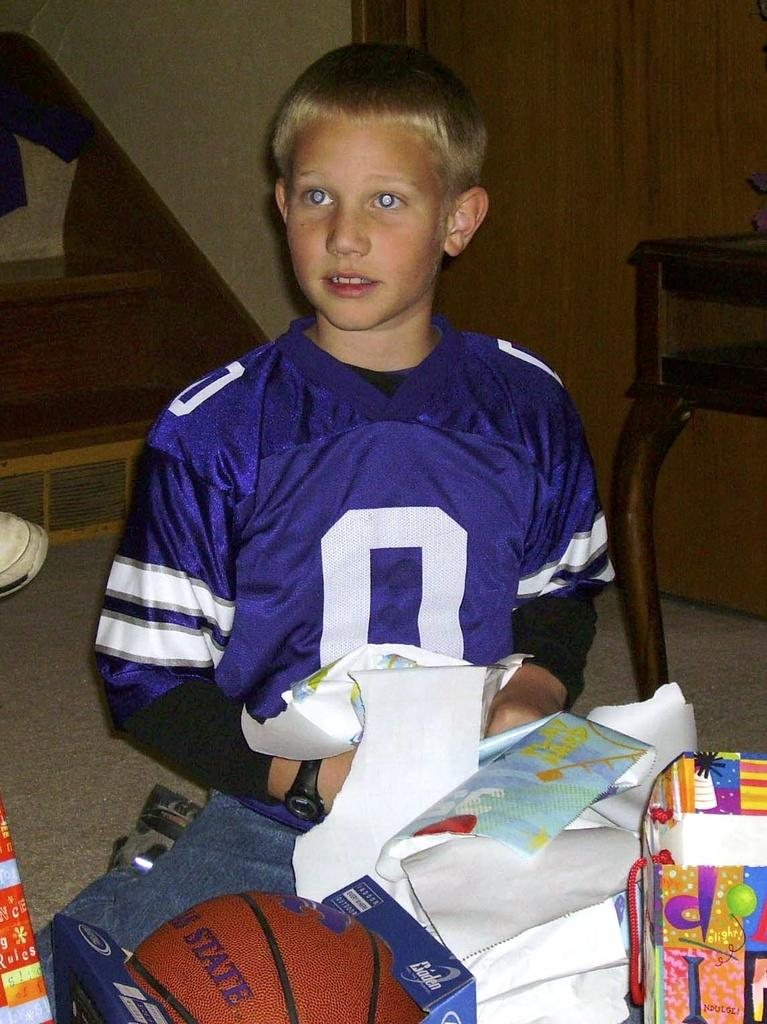<image>
Give a short and clear explanation of the subsequent image. a kid that had a basketball next to him with the word state on it 